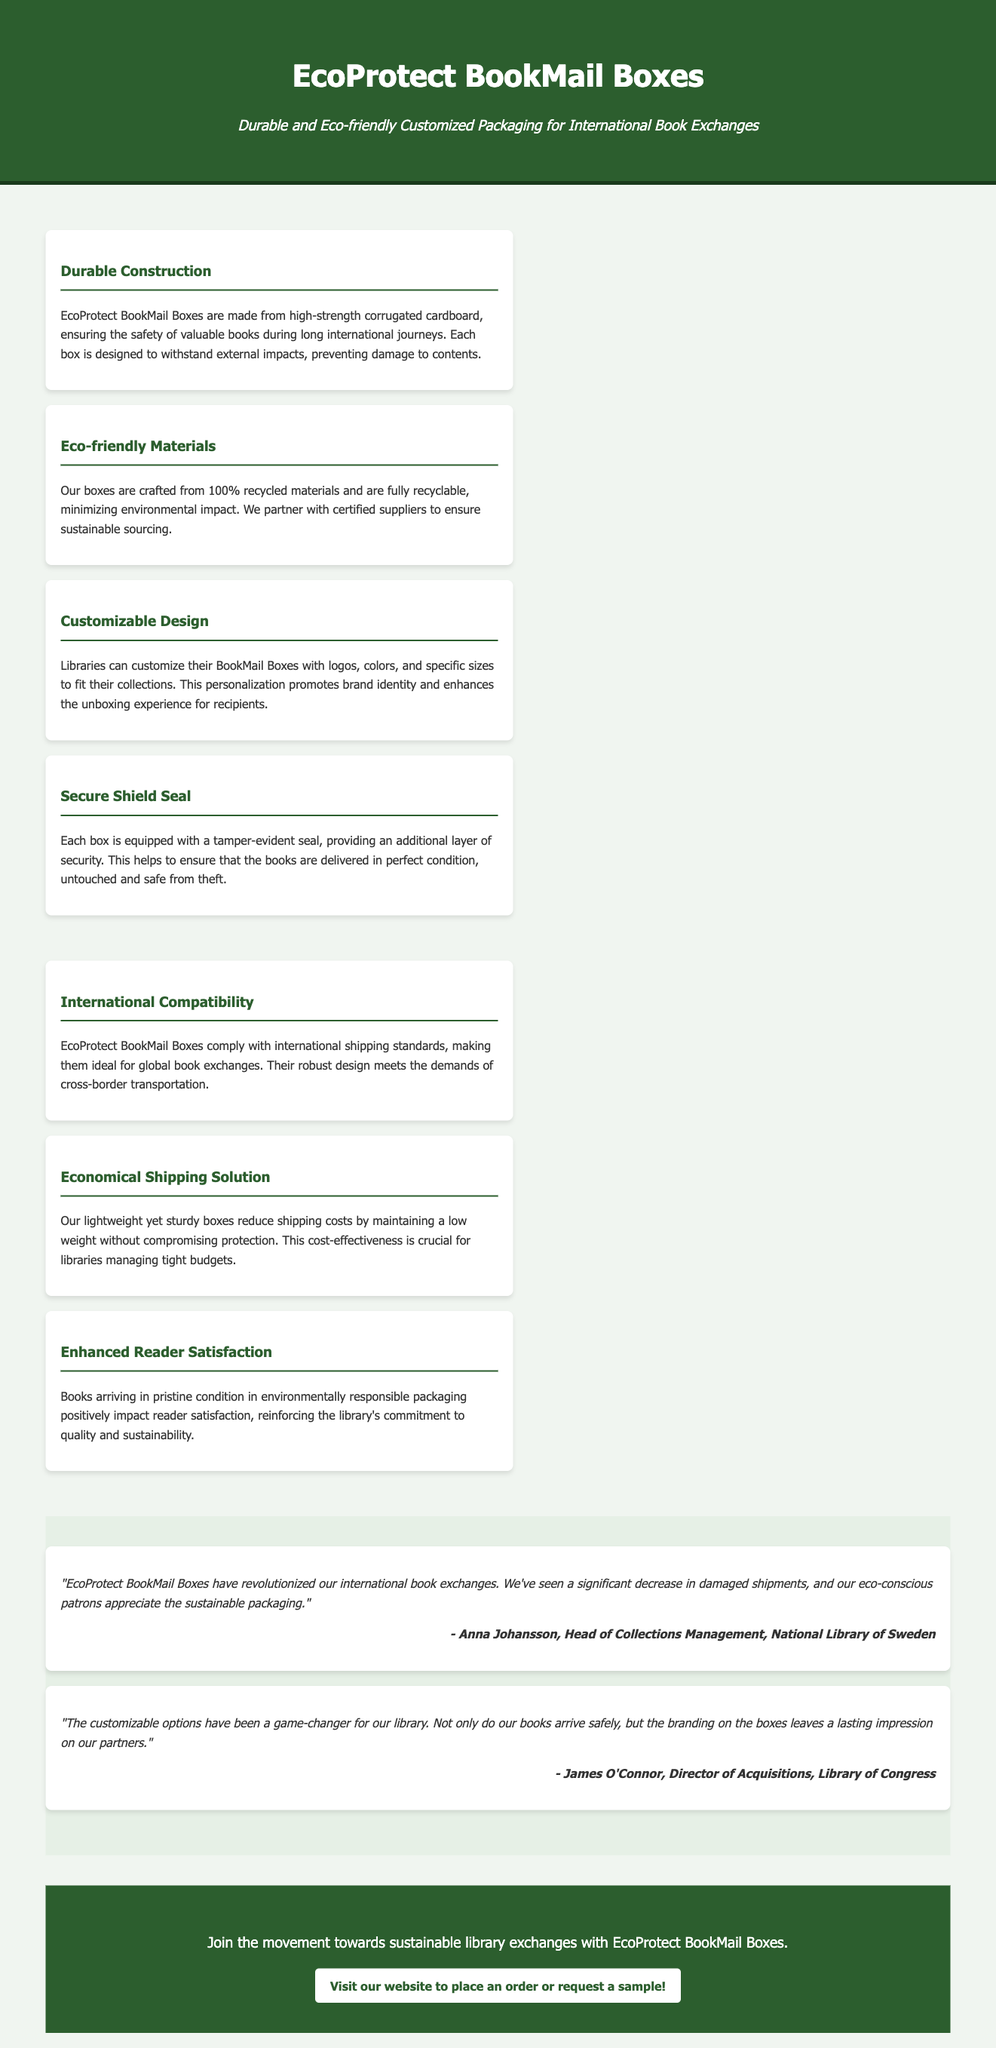What are EcoProtect BookMail Boxes made from? The material used for EcoProtect BookMail Boxes is high-strength corrugated cardboard.
Answer: high-strength corrugated cardboard What is the percentage of recycled materials used? The boxes are crafted from 100% recycled materials.
Answer: 100% What feature ensures security during shipping? The tamper-evident seal provides an additional layer of security for the boxes.
Answer: tamper-evident seal What does customizable design promote? Customizable design promotes brand identity for libraries.
Answer: brand identity Who is the Head of Collections Management mentioned in the testimonials? The testimonial mentions Anna Johansson as the Head of Collections Management.
Answer: Anna Johansson What is the main benefit of lightweight packaging? The lightweight packaging reduces shipping costs for libraries.
Answer: reduces shipping costs Which shipping standard do EcoProtect BookMail Boxes comply with? They comply with international shipping standards, ideal for global book exchanges.
Answer: international shipping standards What is a significant impact on reader satisfaction? Books arriving in pristine condition positively impacts reader satisfaction.
Answer: pristine condition What is the call-to-action at the end of the document? The call-to-action encourages joining the movement towards sustainable library exchanges.
Answer: sustainable library exchanges 